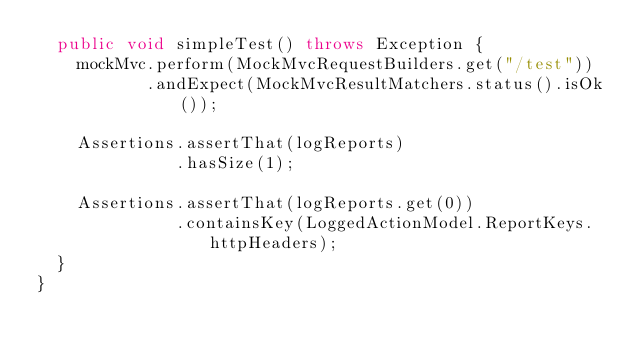Convert code to text. <code><loc_0><loc_0><loc_500><loc_500><_Java_>  public void simpleTest() throws Exception {
    mockMvc.perform(MockMvcRequestBuilders.get("/test"))
           .andExpect(MockMvcResultMatchers.status().isOk());

    Assertions.assertThat(logReports)
              .hasSize(1);

    Assertions.assertThat(logReports.get(0))
              .containsKey(LoggedActionModel.ReportKeys.httpHeaders);
  }
}
</code> 